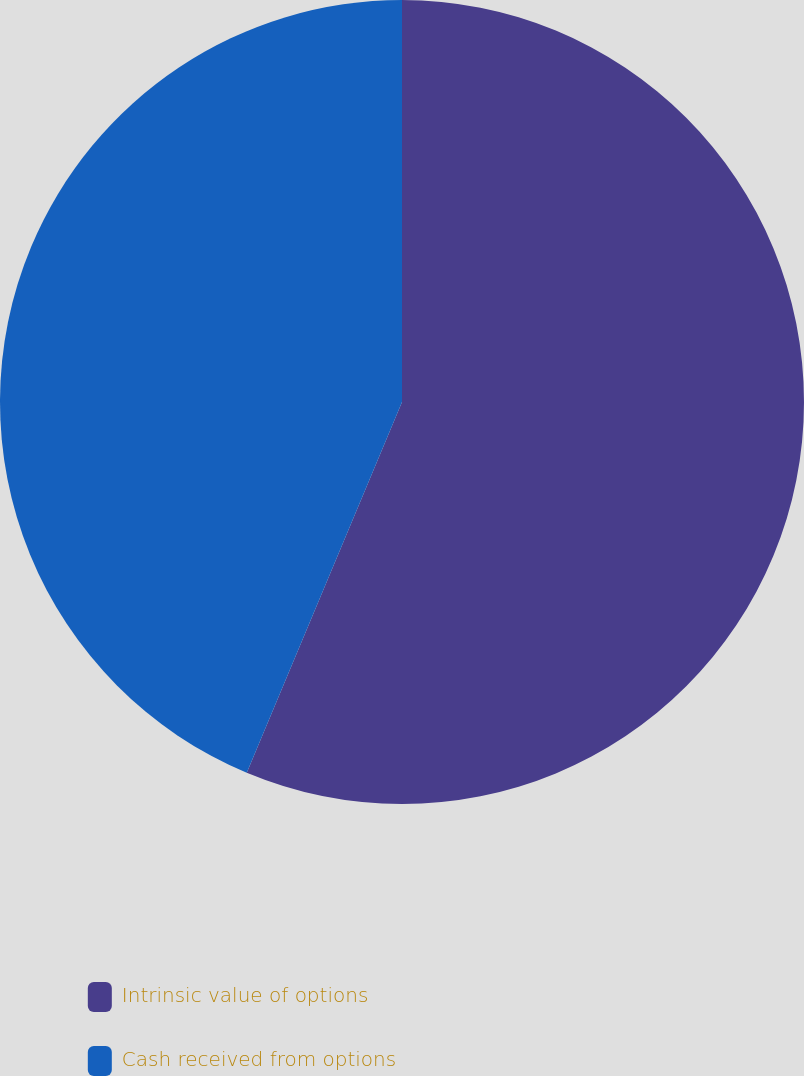<chart> <loc_0><loc_0><loc_500><loc_500><pie_chart><fcel>Intrinsic value of options<fcel>Cash received from options<nl><fcel>56.31%<fcel>43.69%<nl></chart> 